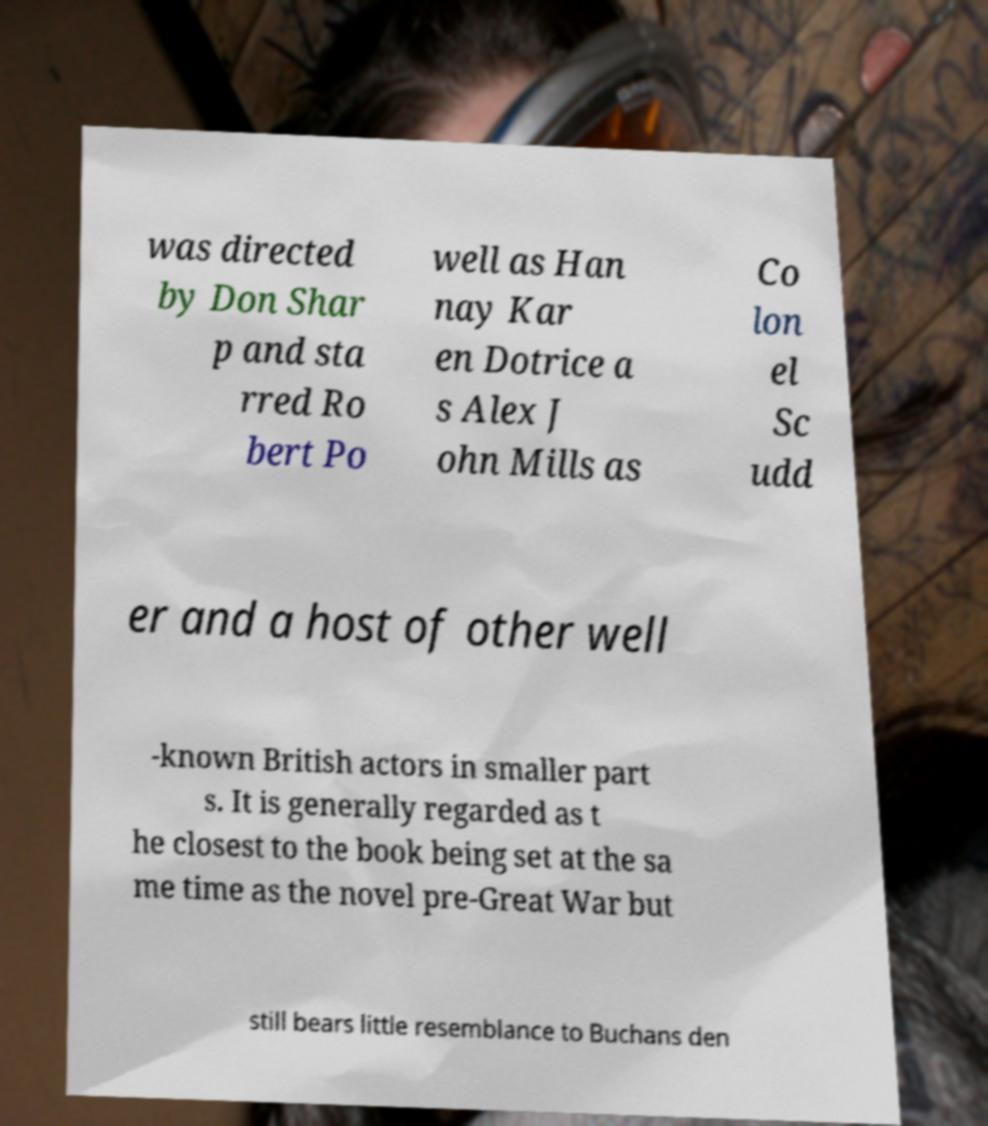For documentation purposes, I need the text within this image transcribed. Could you provide that? was directed by Don Shar p and sta rred Ro bert Po well as Han nay Kar en Dotrice a s Alex J ohn Mills as Co lon el Sc udd er and a host of other well -known British actors in smaller part s. It is generally regarded as t he closest to the book being set at the sa me time as the novel pre-Great War but still bears little resemblance to Buchans den 